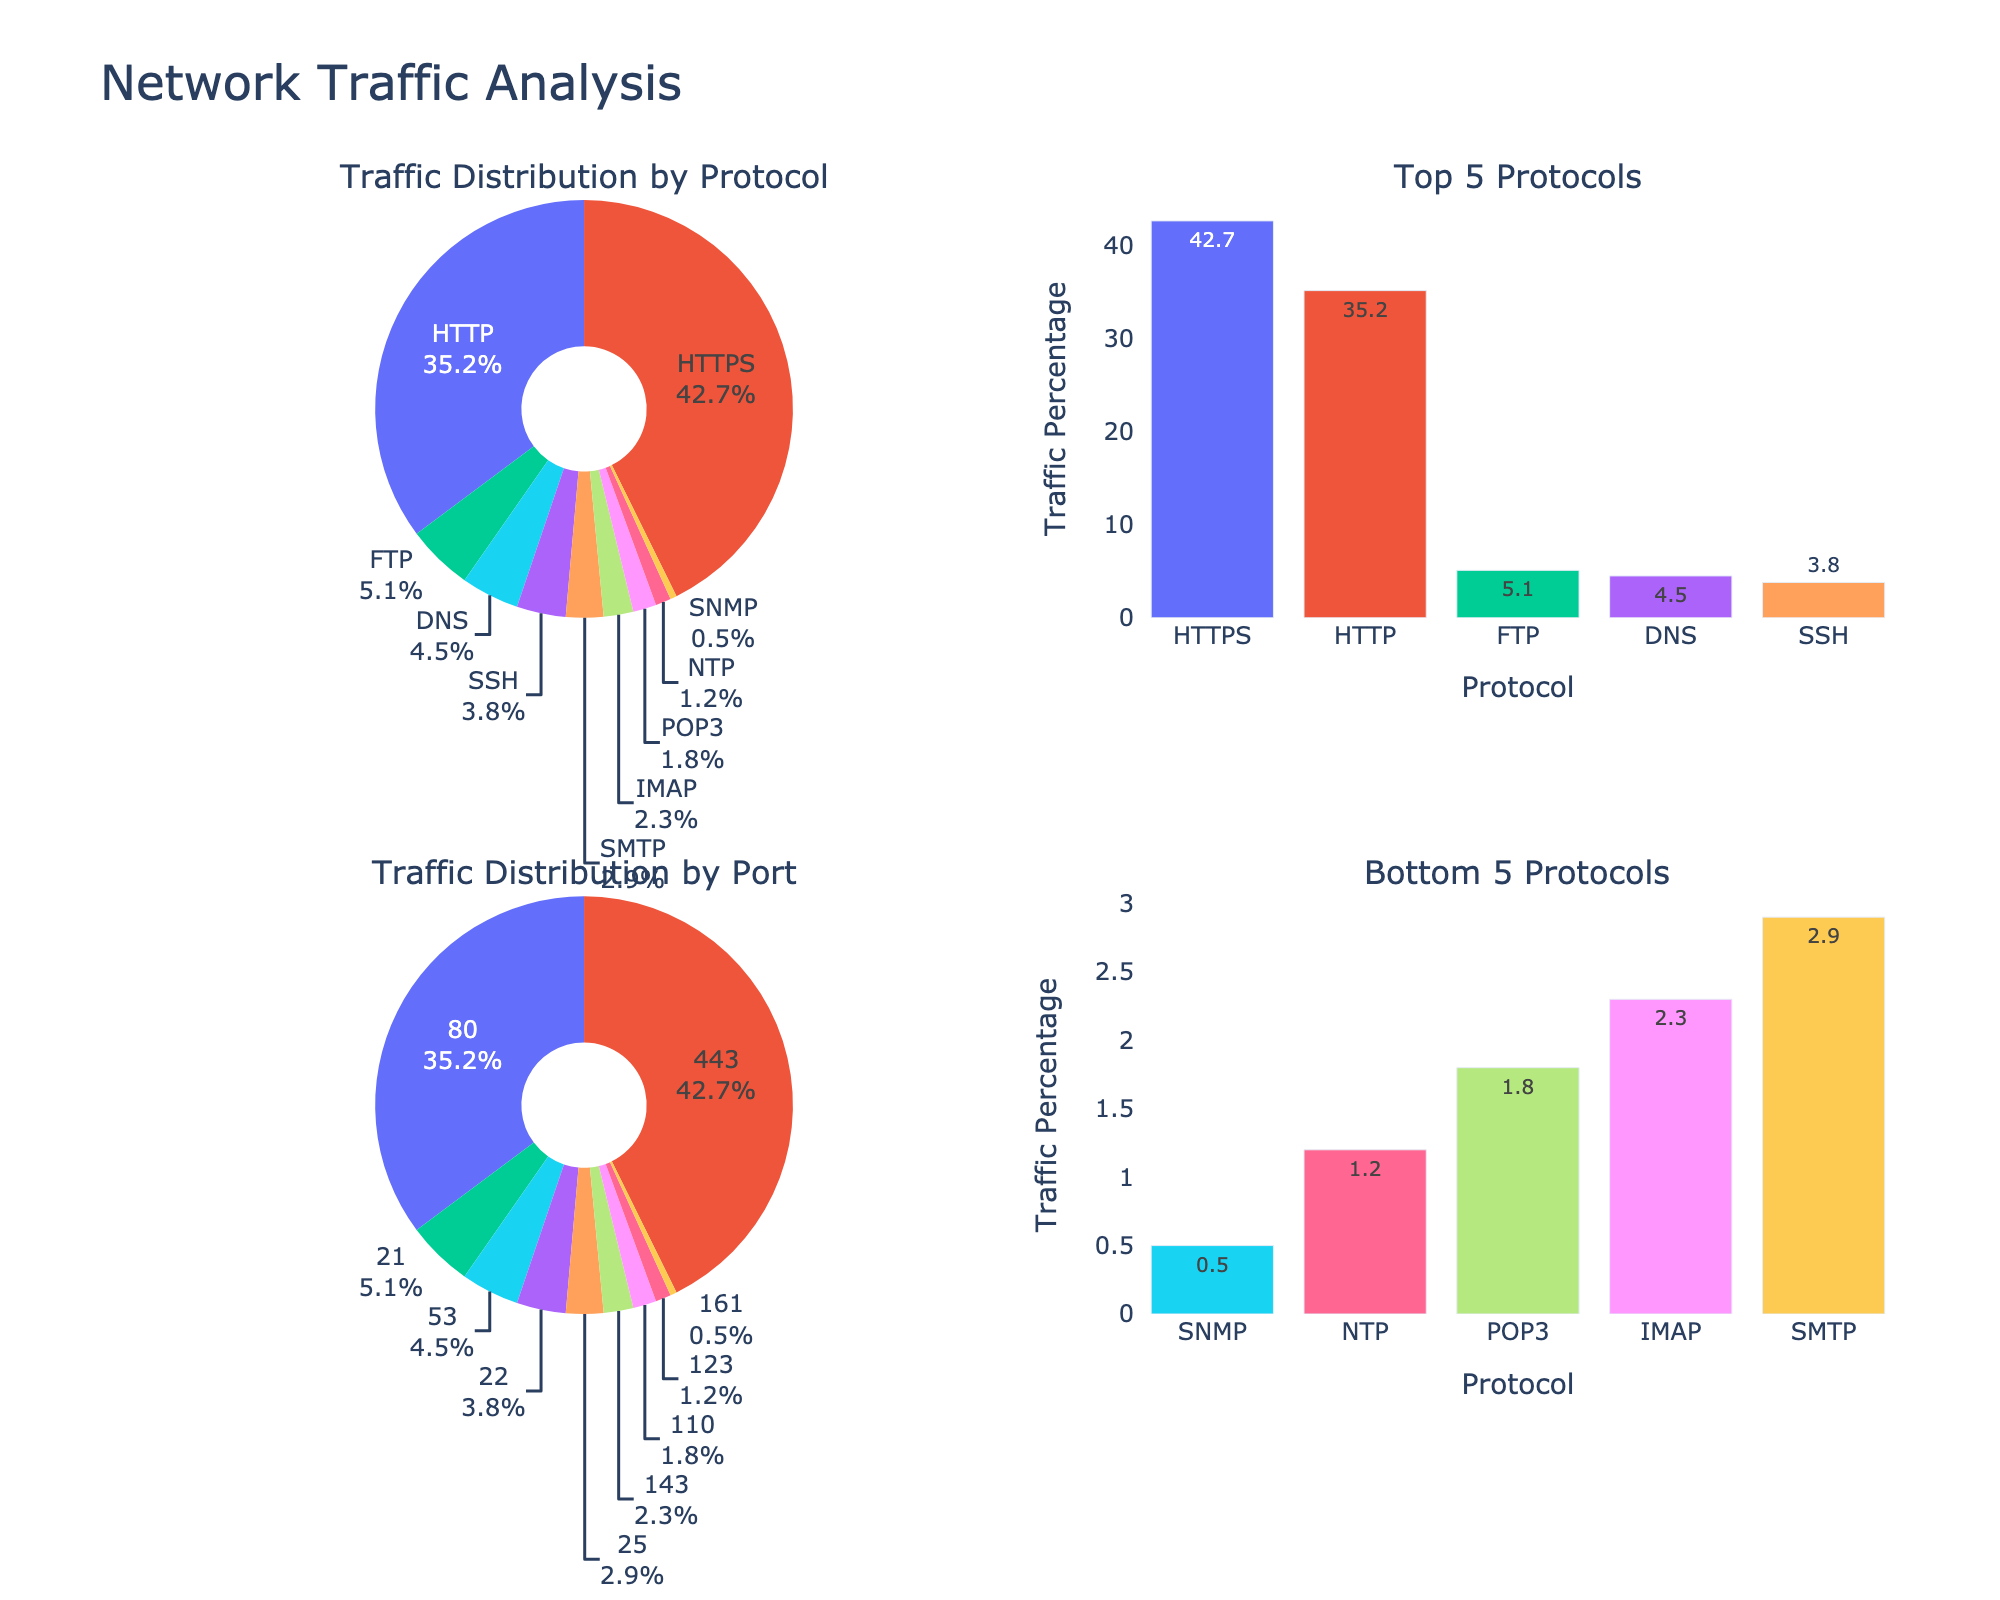Which protocol has the highest traffic percentage? The figure has a bar chart showing the top 5 protocols by traffic percentage. HTTPS is the tallest bar, indicating it has the highest traffic percentage.
Answer: HTTPS What percentage of traffic is carried over HTTP? There is a pie chart showing traffic distribution by protocol. From this pie chart, the section labeled HTTP has a percentage value.
Answer: 35.2% How much more traffic does HTTPS have compared to HTTP? The bar chart for the top 5 protocols shows HTTPS at 42.7% and HTTP at 35.2%. Subtract to find the difference: 42.7% - 35.2% = 7.5%.
Answer: 7.5% What is the combined traffic percentage for FTP, SSH, and SMTP protocols? Refer to the pie chart for traffic distribution by protocol. FTP is 5.1%, SSH is 3.8%, and SMTP is 2.9%. Sum them: 5.1% + 3.8% + 2.9% = 11.8%.
Answer: 11.8% Which protocol has the lowest traffic percentage? There is a bar chart showing the bottom 5 protocols by traffic. SNMP, being the shortest bar, indicates it has the lowest traffic percentage.
Answer: SNMP Are DNS and NTP combined responsible for more traffic than IMAP? DNS has 4.5%, NTP has 1.2%, and IMAP has 2.3% as seen in the pie chart. Sum DNS and NTP to compare to IMAP: 4.5% + 1.2% = 5.7%, which is greater than 2.3%.
Answer: Yes What is the title of the entire figure? The title of the entire figure is displayed at the top and is "Network Traffic Analysis".
Answer: Network Traffic Analysis Which port has the highest traffic percentage? The pie chart for traffic distribution by port shows that port 443 has the largest section, indicating the highest traffic percentage.
Answer: 443 How does the traffic percentage of port 80 compare to port 443? In the pie chart for ports, port 80 is 35.2% and port 443 is 42.7%. Compare the two values to conclude that port 443 has a higher percentage.
Answer: Port 443 has more traffic What are the top 3 protocols by traffic percentage? The bar chart for the top 5 protocols by traffic percentage lists HTTPS, HTTP, and DNS as the top three.
Answer: HTTPS, HTTP, DNS 